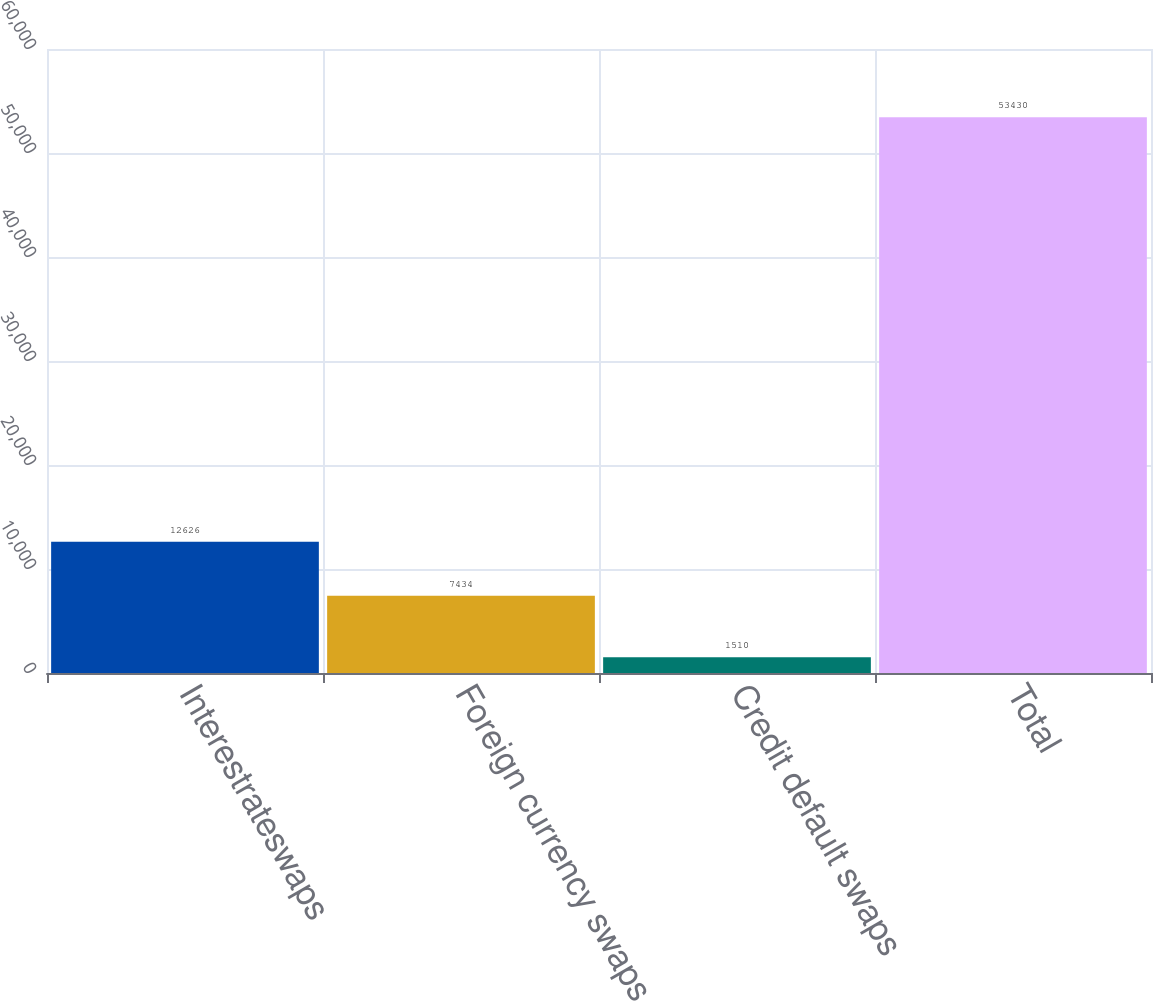Convert chart to OTSL. <chart><loc_0><loc_0><loc_500><loc_500><bar_chart><fcel>Interestrateswaps<fcel>Foreign currency swaps<fcel>Credit default swaps<fcel>Total<nl><fcel>12626<fcel>7434<fcel>1510<fcel>53430<nl></chart> 